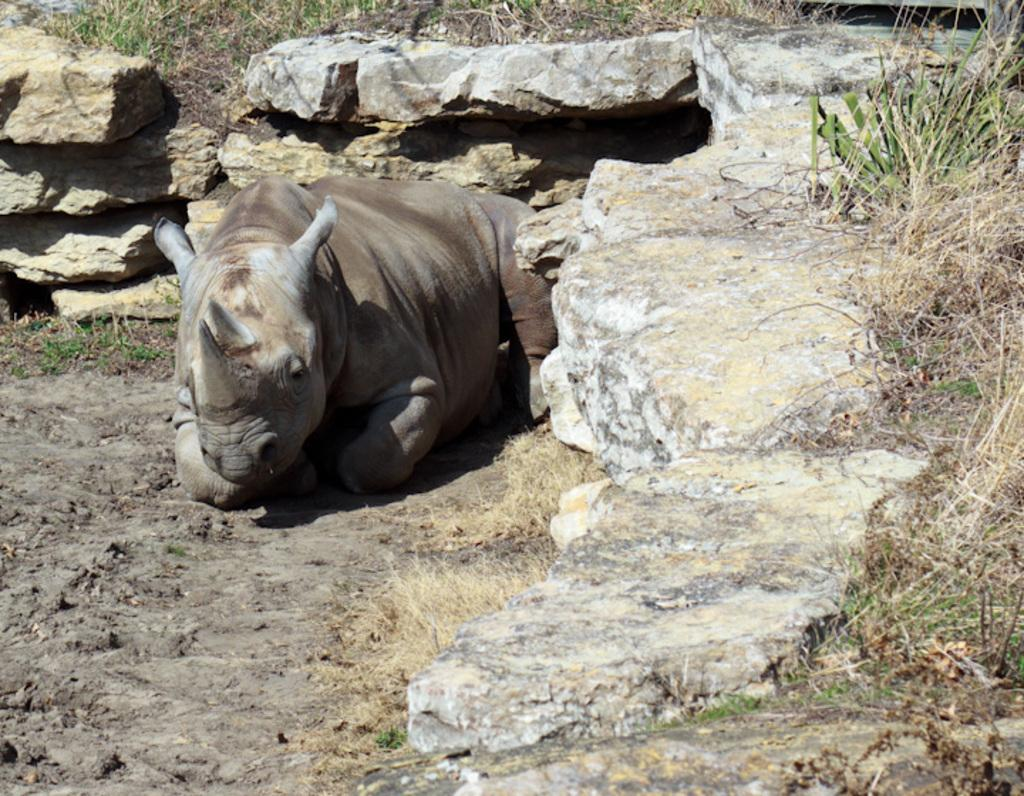What type of animal is in the image? There is an animal in the image, but the specific type cannot be determined from the provided facts. What is the animal doing in the image? The animal is sitting on the ground. What type of terrain is visible in the image? There are rocks and grass visible in the image. What type of polish is the animal using to shine its fur in the image? There is no indication in the image that the animal is using any polish to shine its fur. 